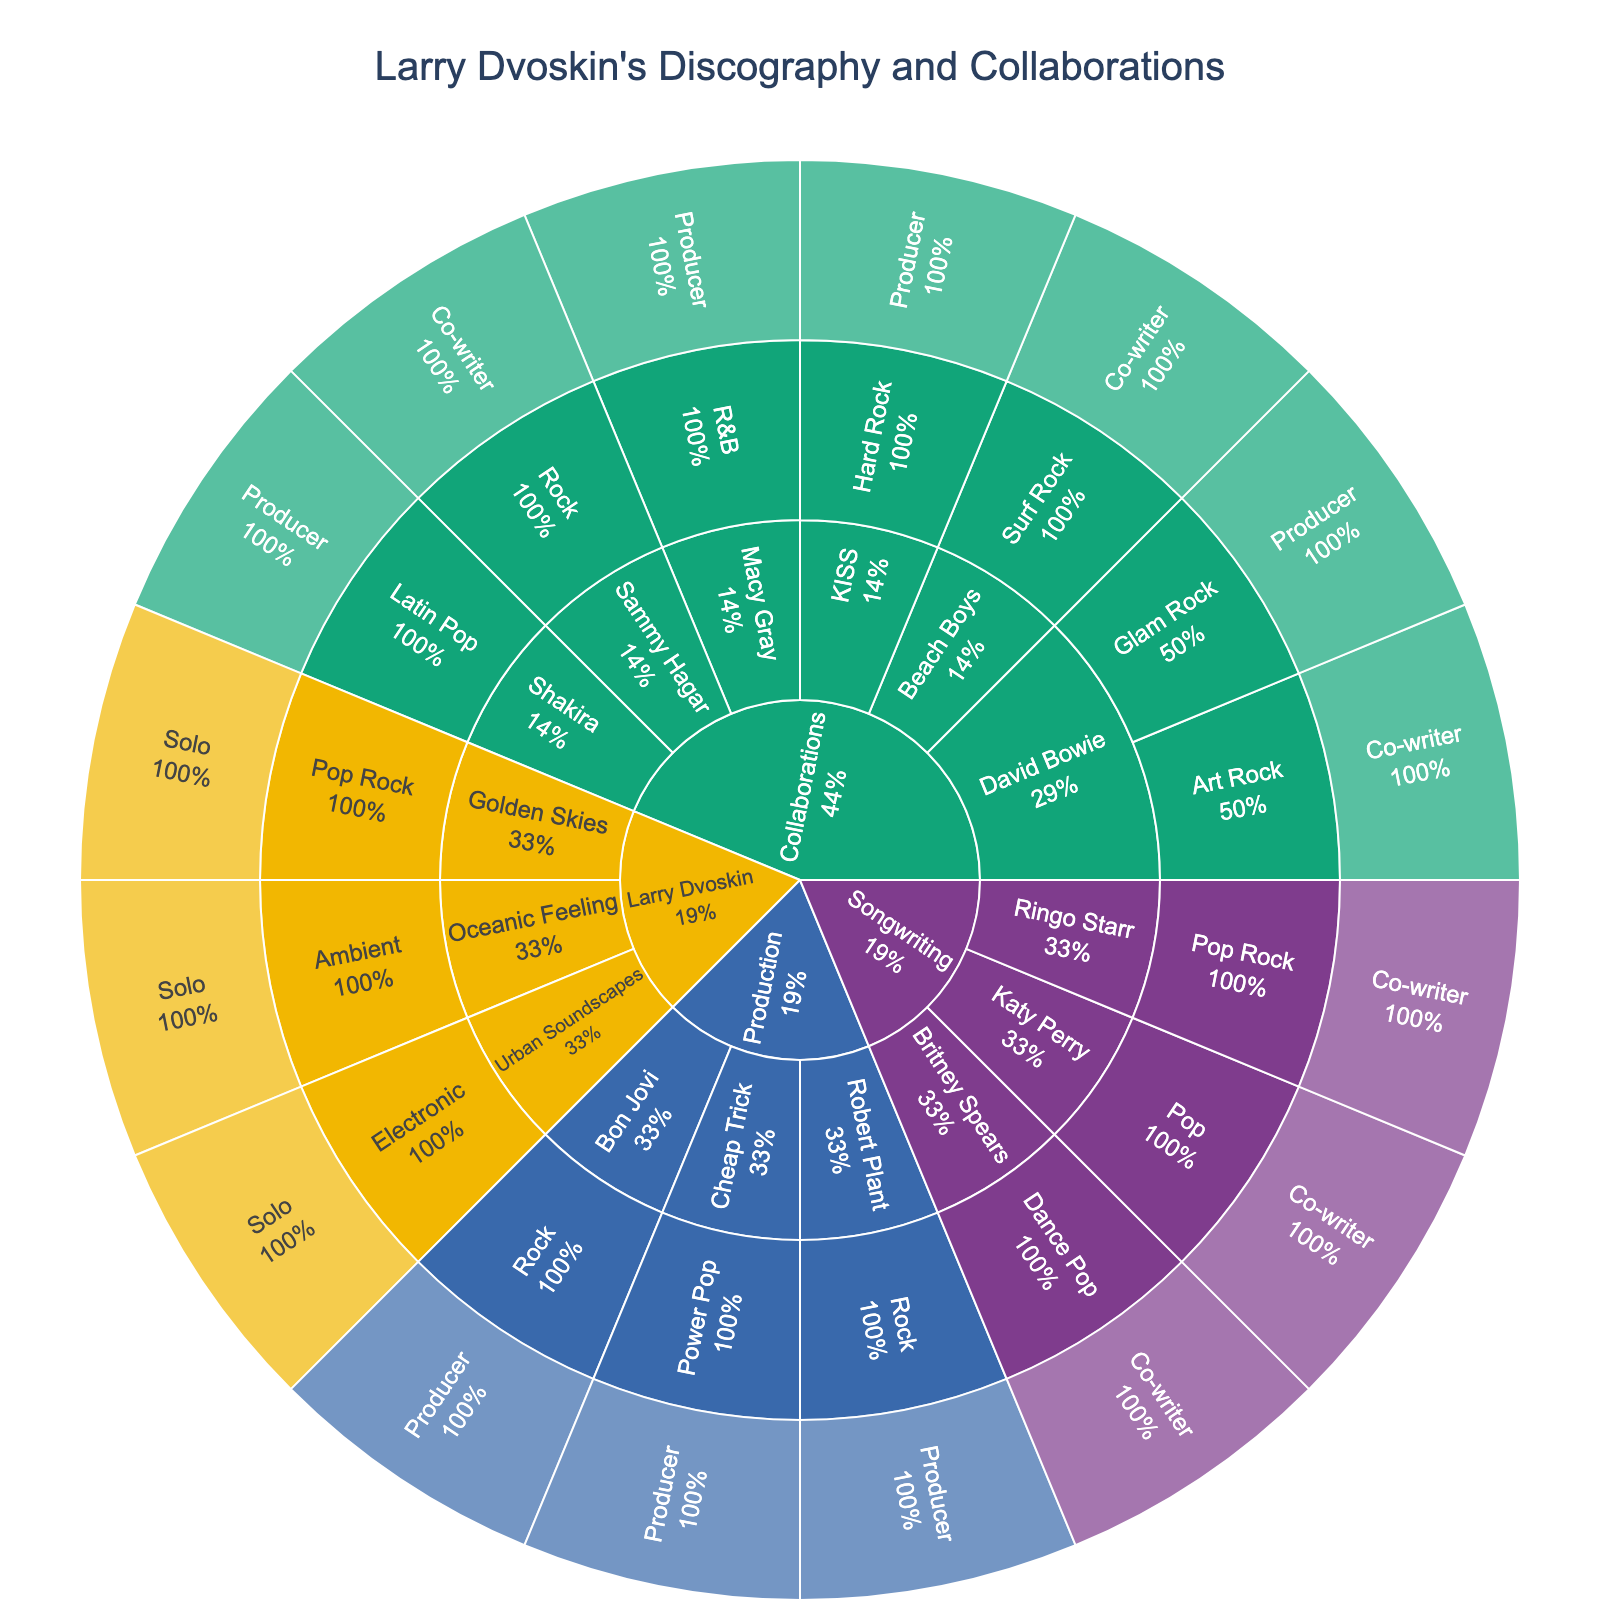Which category has the most entries? By observing the largest section in the Sunburst Plot, we can see the distribution of categories. The 'Collaborations' section has the most entries.
Answer: Collaborations Under the 'Collaborations' category, which artist has the most musical styles represented? We need to look at each artist under 'Collaborations' and count their distinct musical styles. David Bowie appears the most with both 'Glam Rock' and 'Art Rock' represented.
Answer: David Bowie How many solo albums does Larry Dvoskin have? By navigating through the 'Larry Dvoskin' category to the 'Solo' node, we can count the individual albums listed. There are three: 'Golden Skies,' 'Oceanic Feeling,' and 'Urban Soundscapes.'
Answer: 3 What is the only musical style collaboration Larry Dvoskin has with KISS? By following the branch from 'Collaborations' -> 'KISS,' we can observe the musical style listed, which is 'Hard Rock.'
Answer: Hard Rock Compare the number of collaborations Larry Dvoskin has with different artists. Which artist does he have more music production collaborations with, Bon Jovi or Shakira? By checking the 'Production' branch under 'Collaborations,' it's evident that 'Bon Jovi' is listed whereas 'Shakira' is not, indicating that Larry Dvoskin has more music production collaborations with Bon Jovi.
Answer: Bon Jovi Which musical style associated with Larry Dvoskin's solo work does not appear in any of his collaborations? Observing the styles under 'Larry Dvoskin' -> 'Solo,' we see 'Pop Rock,' 'Ambient,' and 'Electronic.' Checking the 'Collaborations' section, only 'Ambient' is unique to Larry's solo work and does not appear in his collaborations.
Answer: Ambient What is the proportion of rock-related musical styles in Larry Dvoskin's collaborations? By summing styles with 'Rock' in them under the 'Collaborations' category ('Glam Rock,' 'Art Rock,' 'Hard Rock,' 'Surf Rock,' 'Rock'), we get 5 out of 7 (counting unique styles), implying that 5/7 of the collaboration styles are rock-related.
Answer: 5/7 or approximately 71% Under the 'Songwriting' category, identify if there is an equal number of pop and rock-related entries. By examining 'Pop' and 'Pop Rock' under 'Songwriting,' there are 'Britney Spears,' 'Katy Perry,' and 'Ringo Starr.' Britney Spears and Katy Perry are under 'Pop,' while Ringo Starr is under 'Pop Rock,' so it is not equal (2 Pop vs. 1 Pop Rock).
Answer: No Which artist appears under multiple categories? By exploring through the plot, it's noticeable that David Bowie shows up under both 'Collaborations' and 'Co-writer'.
Answer: David Bowie 